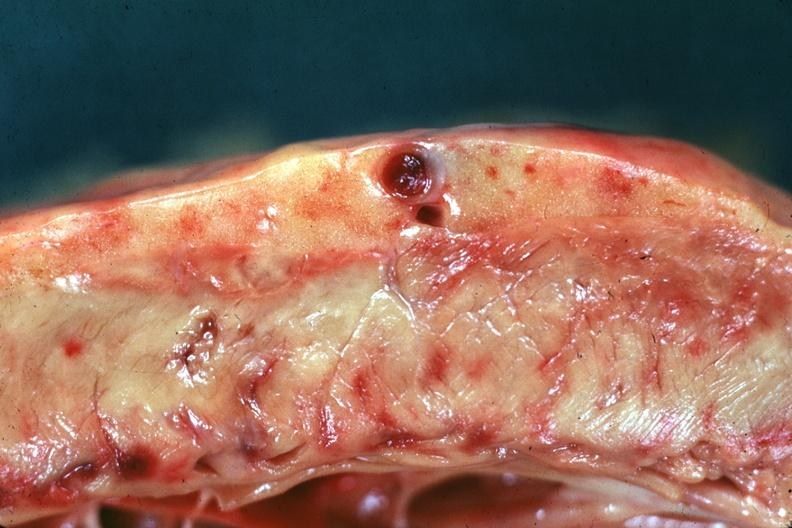s prostate present?
Answer the question using a single word or phrase. Yes 